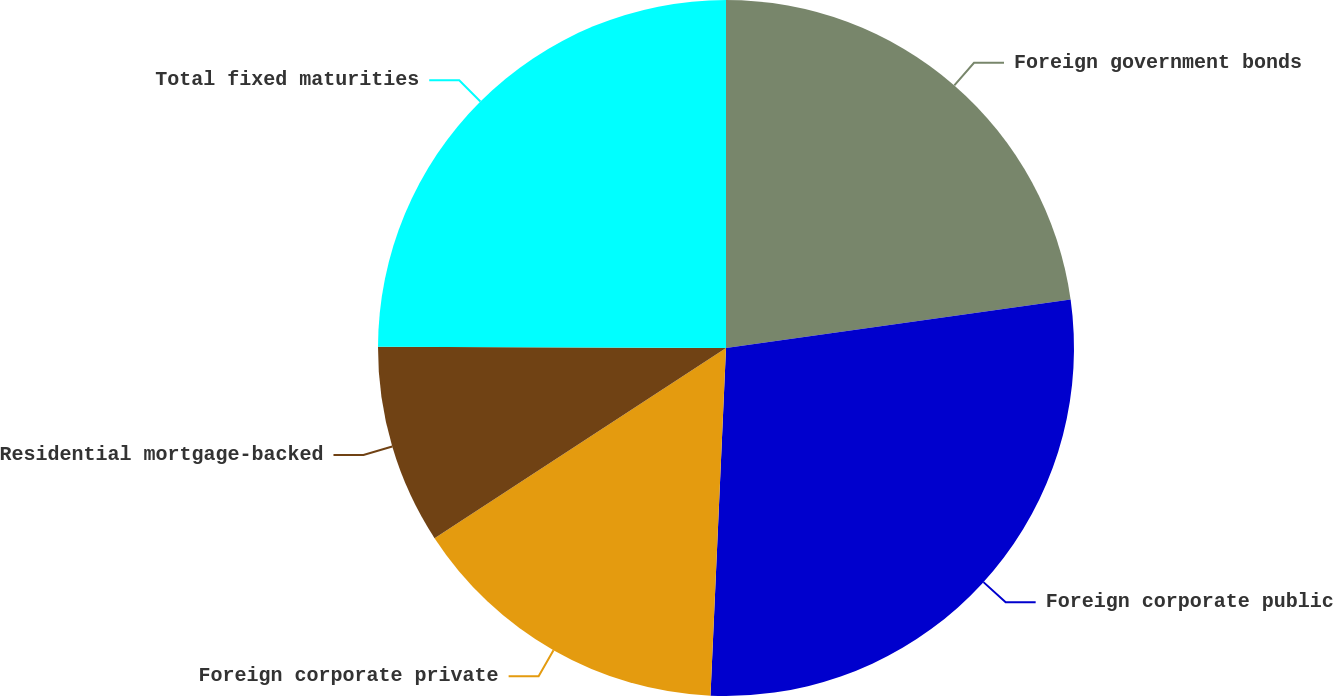Convert chart to OTSL. <chart><loc_0><loc_0><loc_500><loc_500><pie_chart><fcel>Foreign government bonds<fcel>Foreign corporate public<fcel>Foreign corporate private<fcel>Residential mortgage-backed<fcel>Total fixed maturities<nl><fcel>22.78%<fcel>27.93%<fcel>15.09%<fcel>9.26%<fcel>24.94%<nl></chart> 